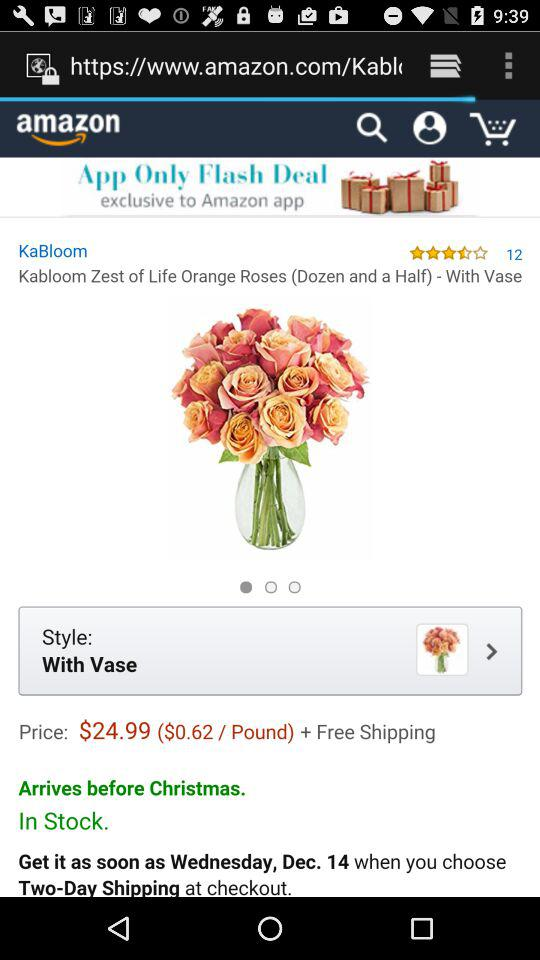How much does the shipping cost?
Answer the question using a single word or phrase. Shipping is free. 